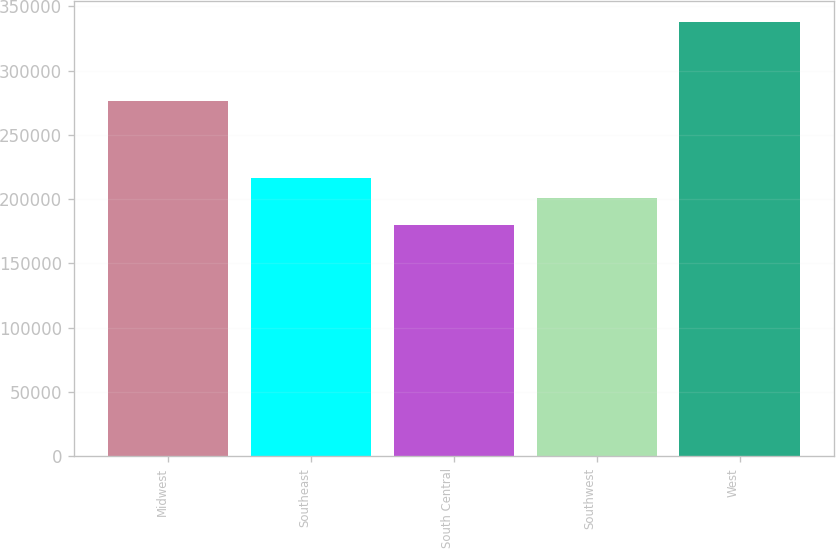<chart> <loc_0><loc_0><loc_500><loc_500><bar_chart><fcel>Midwest<fcel>Southeast<fcel>South Central<fcel>Southwest<fcel>West<nl><fcel>276000<fcel>216670<fcel>179700<fcel>200900<fcel>337400<nl></chart> 